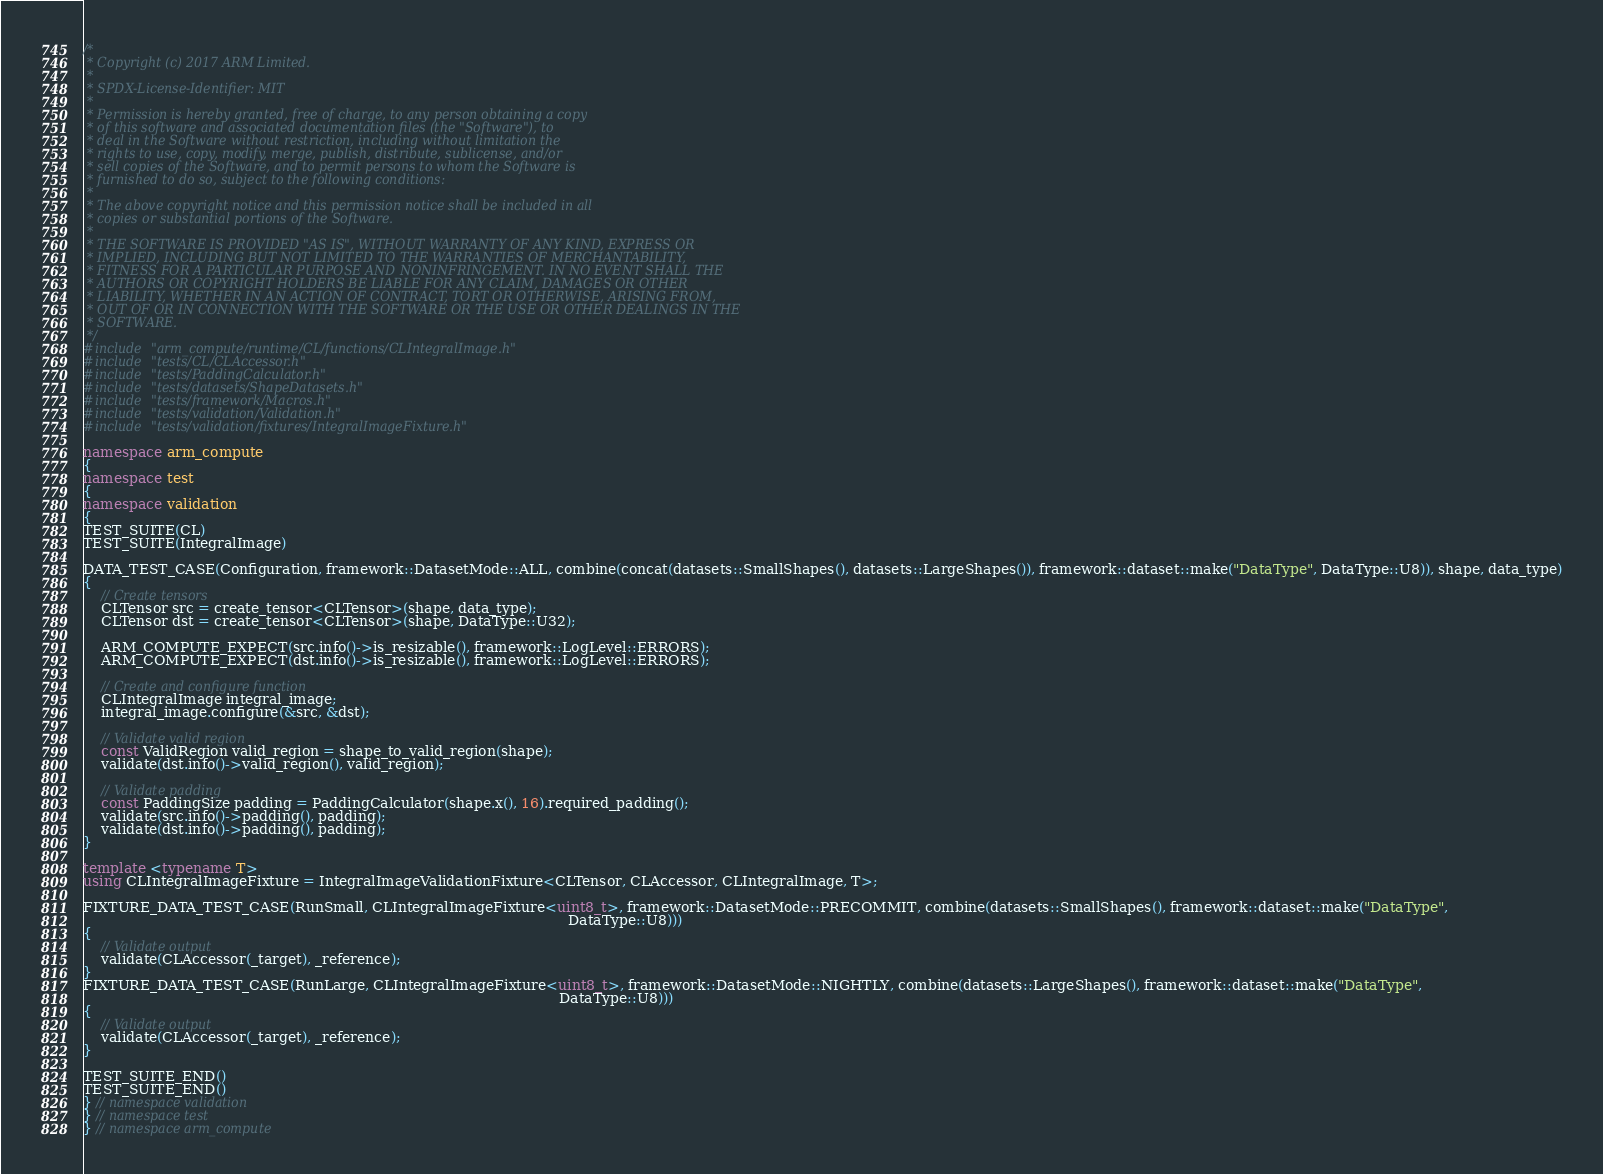<code> <loc_0><loc_0><loc_500><loc_500><_C++_>/*
 * Copyright (c) 2017 ARM Limited.
 *
 * SPDX-License-Identifier: MIT
 *
 * Permission is hereby granted, free of charge, to any person obtaining a copy
 * of this software and associated documentation files (the "Software"), to
 * deal in the Software without restriction, including without limitation the
 * rights to use, copy, modify, merge, publish, distribute, sublicense, and/or
 * sell copies of the Software, and to permit persons to whom the Software is
 * furnished to do so, subject to the following conditions:
 *
 * The above copyright notice and this permission notice shall be included in all
 * copies or substantial portions of the Software.
 *
 * THE SOFTWARE IS PROVIDED "AS IS", WITHOUT WARRANTY OF ANY KIND, EXPRESS OR
 * IMPLIED, INCLUDING BUT NOT LIMITED TO THE WARRANTIES OF MERCHANTABILITY,
 * FITNESS FOR A PARTICULAR PURPOSE AND NONINFRINGEMENT. IN NO EVENT SHALL THE
 * AUTHORS OR COPYRIGHT HOLDERS BE LIABLE FOR ANY CLAIM, DAMAGES OR OTHER
 * LIABILITY, WHETHER IN AN ACTION OF CONTRACT, TORT OR OTHERWISE, ARISING FROM,
 * OUT OF OR IN CONNECTION WITH THE SOFTWARE OR THE USE OR OTHER DEALINGS IN THE
 * SOFTWARE.
 */
#include "arm_compute/runtime/CL/functions/CLIntegralImage.h"
#include "tests/CL/CLAccessor.h"
#include "tests/PaddingCalculator.h"
#include "tests/datasets/ShapeDatasets.h"
#include "tests/framework/Macros.h"
#include "tests/validation/Validation.h"
#include "tests/validation/fixtures/IntegralImageFixture.h"

namespace arm_compute
{
namespace test
{
namespace validation
{
TEST_SUITE(CL)
TEST_SUITE(IntegralImage)

DATA_TEST_CASE(Configuration, framework::DatasetMode::ALL, combine(concat(datasets::SmallShapes(), datasets::LargeShapes()), framework::dataset::make("DataType", DataType::U8)), shape, data_type)
{
    // Create tensors
    CLTensor src = create_tensor<CLTensor>(shape, data_type);
    CLTensor dst = create_tensor<CLTensor>(shape, DataType::U32);

    ARM_COMPUTE_EXPECT(src.info()->is_resizable(), framework::LogLevel::ERRORS);
    ARM_COMPUTE_EXPECT(dst.info()->is_resizable(), framework::LogLevel::ERRORS);

    // Create and configure function
    CLIntegralImage integral_image;
    integral_image.configure(&src, &dst);

    // Validate valid region
    const ValidRegion valid_region = shape_to_valid_region(shape);
    validate(dst.info()->valid_region(), valid_region);

    // Validate padding
    const PaddingSize padding = PaddingCalculator(shape.x(), 16).required_padding();
    validate(src.info()->padding(), padding);
    validate(dst.info()->padding(), padding);
}

template <typename T>
using CLIntegralImageFixture = IntegralImageValidationFixture<CLTensor, CLAccessor, CLIntegralImage, T>;

FIXTURE_DATA_TEST_CASE(RunSmall, CLIntegralImageFixture<uint8_t>, framework::DatasetMode::PRECOMMIT, combine(datasets::SmallShapes(), framework::dataset::make("DataType",
                                                                                                             DataType::U8)))
{
    // Validate output
    validate(CLAccessor(_target), _reference);
}
FIXTURE_DATA_TEST_CASE(RunLarge, CLIntegralImageFixture<uint8_t>, framework::DatasetMode::NIGHTLY, combine(datasets::LargeShapes(), framework::dataset::make("DataType",
                                                                                                           DataType::U8)))
{
    // Validate output
    validate(CLAccessor(_target), _reference);
}

TEST_SUITE_END()
TEST_SUITE_END()
} // namespace validation
} // namespace test
} // namespace arm_compute
</code> 